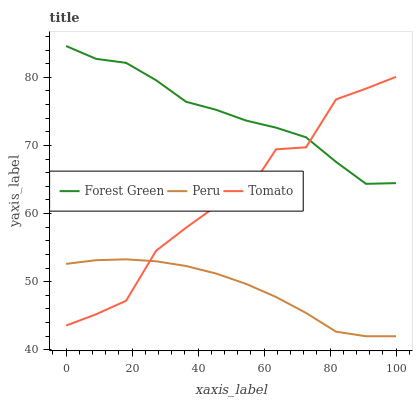Does Peru have the minimum area under the curve?
Answer yes or no. Yes. Does Forest Green have the maximum area under the curve?
Answer yes or no. Yes. Does Forest Green have the minimum area under the curve?
Answer yes or no. No. Does Peru have the maximum area under the curve?
Answer yes or no. No. Is Peru the smoothest?
Answer yes or no. Yes. Is Tomato the roughest?
Answer yes or no. Yes. Is Forest Green the smoothest?
Answer yes or no. No. Is Forest Green the roughest?
Answer yes or no. No. Does Peru have the lowest value?
Answer yes or no. Yes. Does Forest Green have the lowest value?
Answer yes or no. No. Does Forest Green have the highest value?
Answer yes or no. Yes. Does Peru have the highest value?
Answer yes or no. No. Is Peru less than Forest Green?
Answer yes or no. Yes. Is Forest Green greater than Peru?
Answer yes or no. Yes. Does Tomato intersect Peru?
Answer yes or no. Yes. Is Tomato less than Peru?
Answer yes or no. No. Is Tomato greater than Peru?
Answer yes or no. No. Does Peru intersect Forest Green?
Answer yes or no. No. 